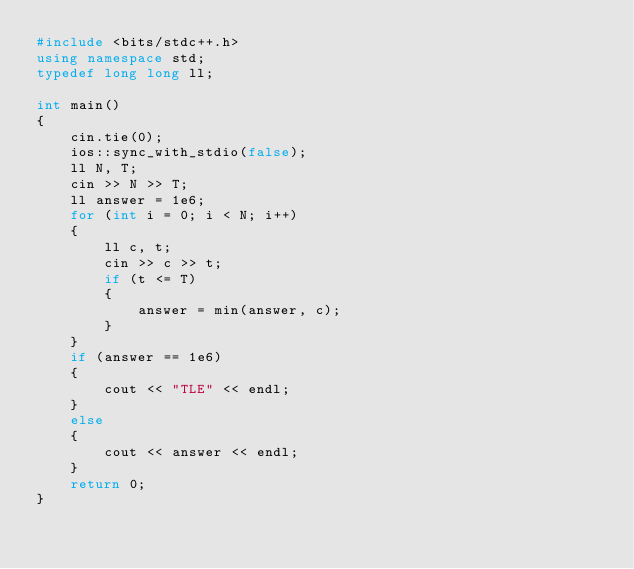Convert code to text. <code><loc_0><loc_0><loc_500><loc_500><_C++_>#include <bits/stdc++.h>
using namespace std;
typedef long long ll;

int main()
{
    cin.tie(0);
    ios::sync_with_stdio(false);
    ll N, T;
    cin >> N >> T;
    ll answer = 1e6;
    for (int i = 0; i < N; i++)
    {
        ll c, t;
        cin >> c >> t;
        if (t <= T)
        {
            answer = min(answer, c);
        }
    }
    if (answer == 1e6)
    {
        cout << "TLE" << endl;
    }
    else
    {
        cout << answer << endl;
    }
    return 0;
}
</code> 